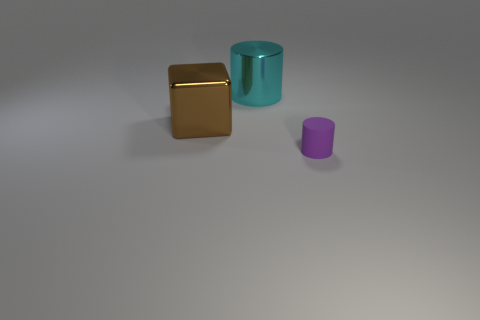Add 3 big metal spheres. How many objects exist? 6 Subtract all cylinders. How many objects are left? 1 Add 3 big brown metallic blocks. How many big brown metallic blocks are left? 4 Add 3 tiny metal cylinders. How many tiny metal cylinders exist? 3 Subtract 0 gray cylinders. How many objects are left? 3 Subtract all metal cylinders. Subtract all small cylinders. How many objects are left? 1 